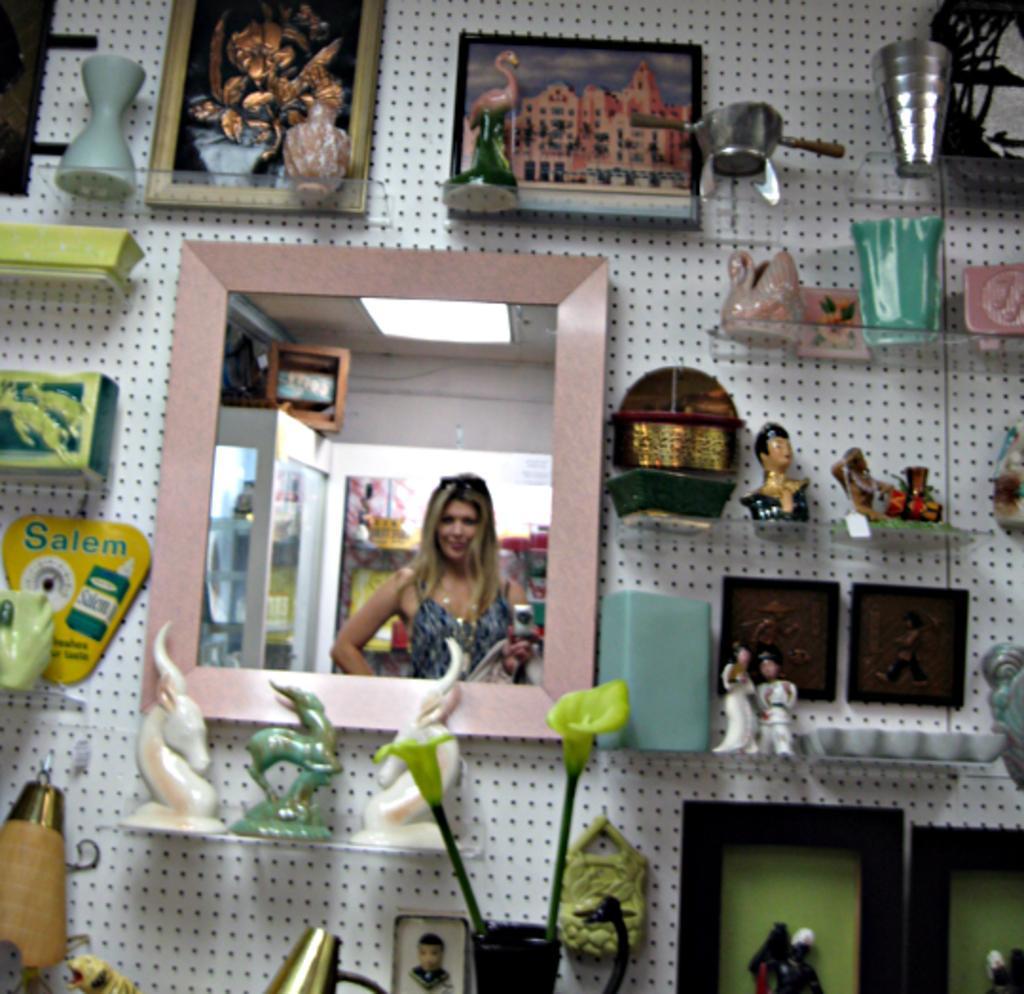Could you give a brief overview of what you see in this image? In the picture we can see a wall with small holes to it and to it we can see a mirror, some sculptures, and some glass racks, and some things placed on it. 